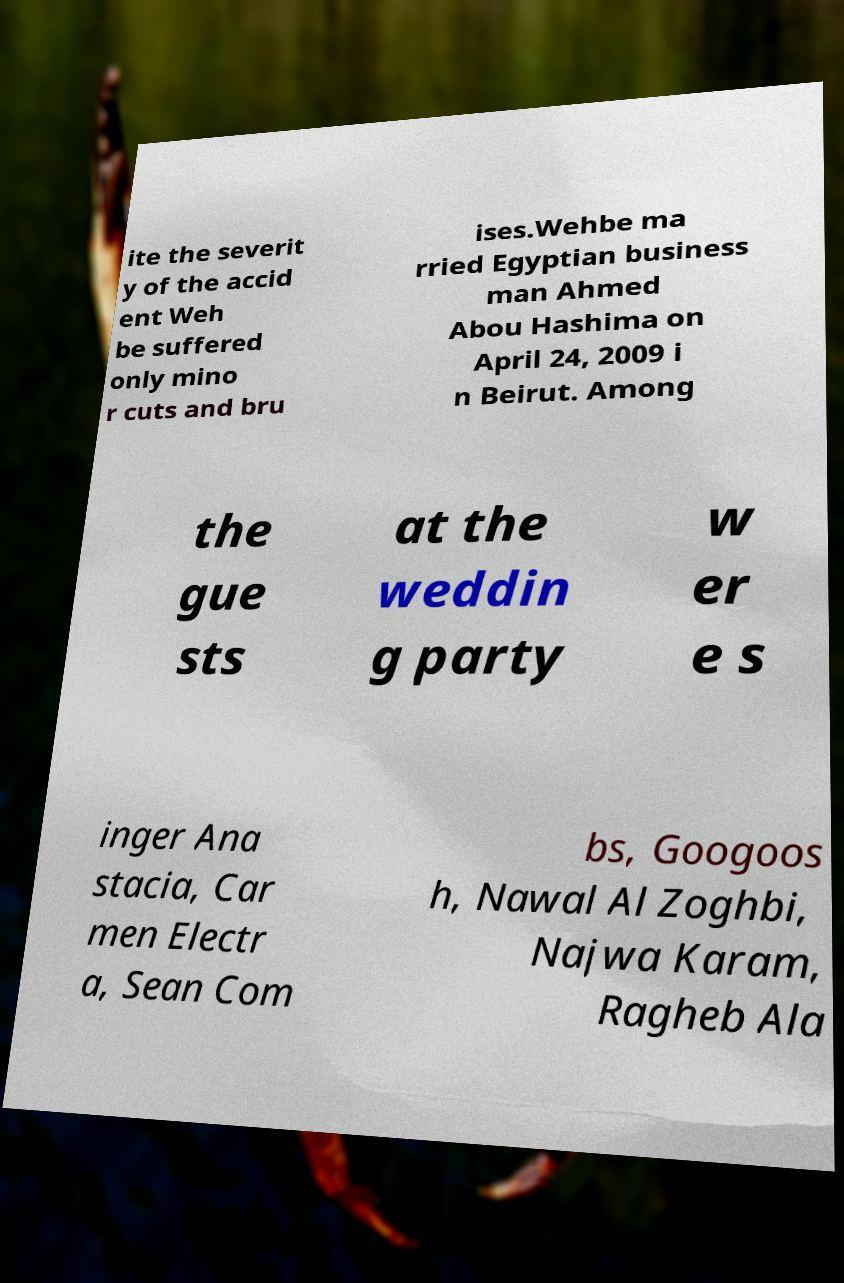I need the written content from this picture converted into text. Can you do that? ite the severit y of the accid ent Weh be suffered only mino r cuts and bru ises.Wehbe ma rried Egyptian business man Ahmed Abou Hashima on April 24, 2009 i n Beirut. Among the gue sts at the weddin g party w er e s inger Ana stacia, Car men Electr a, Sean Com bs, Googoos h, Nawal Al Zoghbi, Najwa Karam, Ragheb Ala 